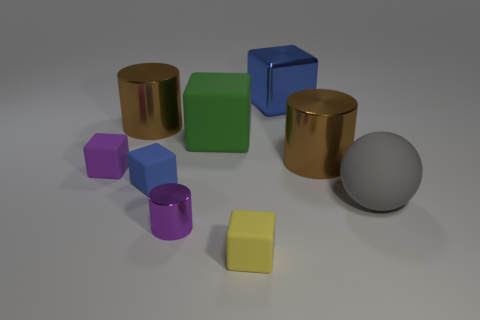What number of other things are there of the same color as the small metal cylinder?
Provide a short and direct response. 1. Are there more large rubber things in front of the tiny blue rubber thing than yellow metallic blocks?
Offer a very short reply. Yes. Is the tiny yellow thing made of the same material as the purple cylinder?
Provide a succinct answer. No. How many objects are tiny rubber blocks right of the tiny blue matte thing or big gray rubber spheres?
Make the answer very short. 2. What number of other objects are the same size as the gray matte sphere?
Your answer should be compact. 4. Are there the same number of brown metallic objects that are left of the large blue metal thing and yellow blocks that are behind the yellow block?
Your response must be concise. No. There is a metallic object that is the same shape as the small yellow rubber thing; what color is it?
Your response must be concise. Blue. Is there anything else that has the same shape as the gray matte object?
Your answer should be compact. No. Does the tiny rubber cube that is left of the tiny blue block have the same color as the small cylinder?
Give a very brief answer. Yes. What size is the other blue thing that is the same shape as the big blue object?
Give a very brief answer. Small. 